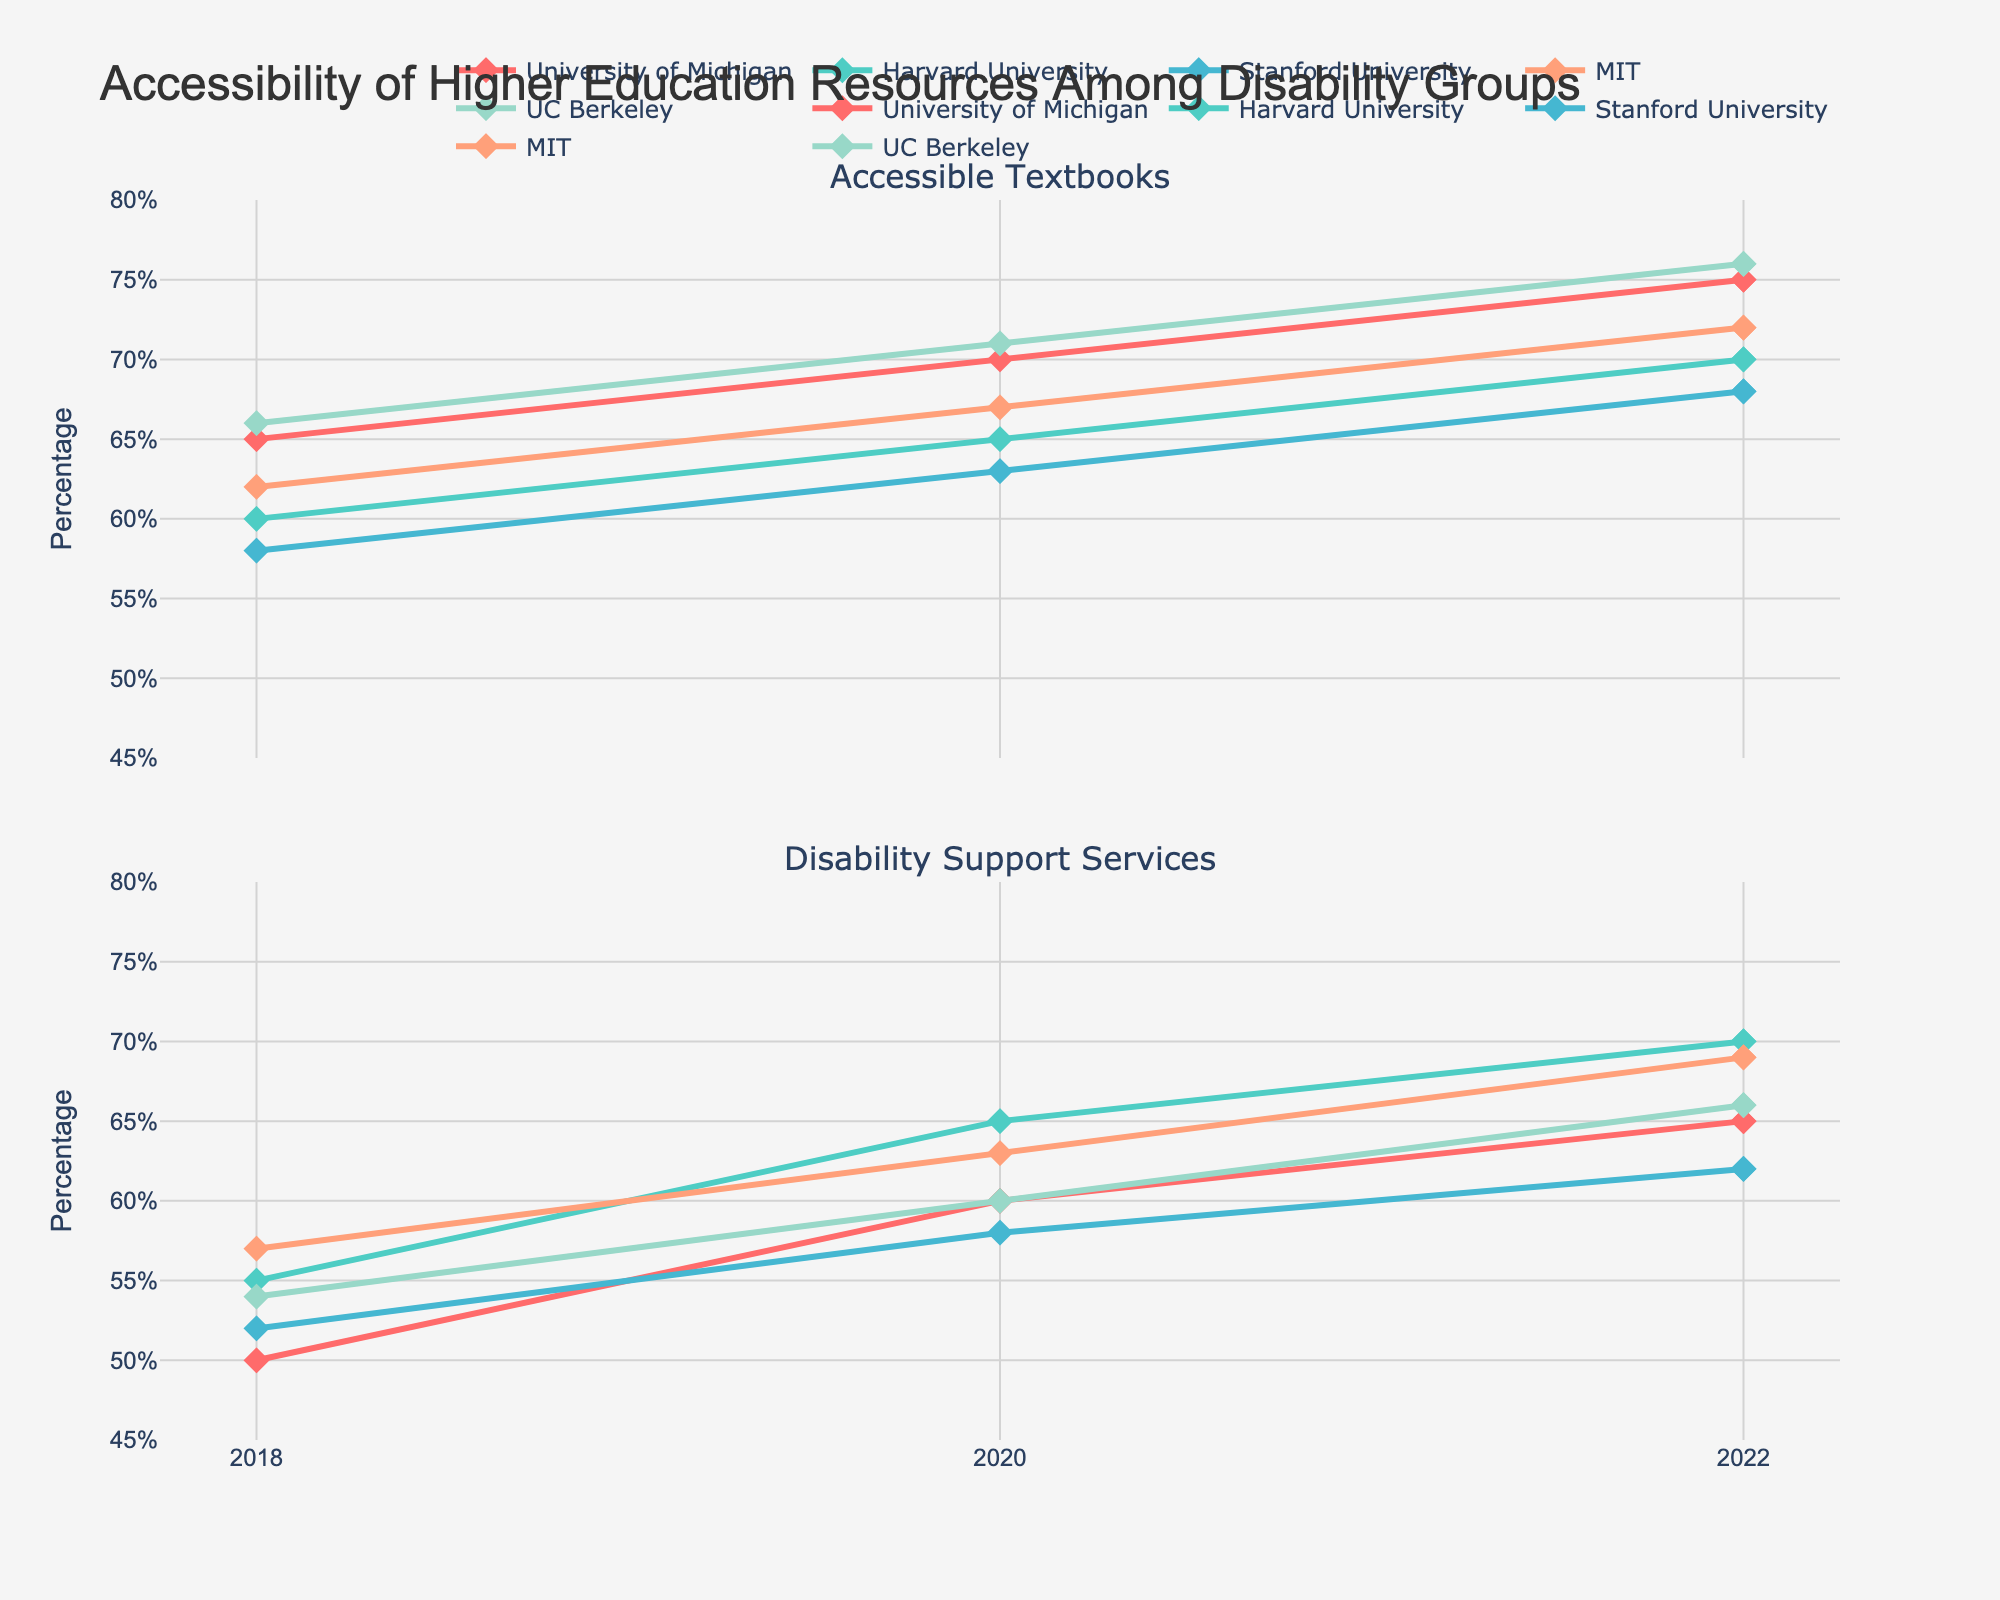What is the title of the figure? The title of the figure is typically displayed prominently at the top of the graph.
Answer: Accessibility of Higher Education Resources Among Disability Groups How many institutions are displayed in the figure? By analyzing the legend or the distinct lines representing different institutions, we can count the number of institutions.
Answer: Five Which institution had the highest percentage of accessible textbooks in 2022? By observing the 'Accessible Textbooks' subplot for 2022 and comparing the endpoints of the lines, the institution with the highest percentage can be identified.
Answer: UC Berkeley What was the percentage increase in accessible textbooks at the University of Michigan from 2018 to 2022? Subtract 2018's percentage from 2022's percentage for the University of Michigan in the 'Accessible Textbooks' subplot: 75% - 65% = 10%.
Answer: 10% Which resource saw the largest improvement at MIT between 2018 and 2022? Compare the changes in percentages for both resources at MIT between 2018 and 2022 to determine the larger improvement. Accessible Textbooks: 72% - 62% = 10%. Disability Support Services: 69% - 57% = 12%.
Answer: Disability Support Services Did any institution have a decrease in either resource from 2018 to 2022? Examine the endpoints of all lines in both subplots; none should show a decline from left to right.
Answer: No Between Harvard and Stanford, which institution had a higher percentage of disability support services in 2020? Compare the data points for 'Disability Support Services' in 2020 for both Harvard and Stanford.
Answer: Harvard What is the average percentage of accessible textbooks across all institutions in 2022? Add the percentages for accessible textbooks in 2022 for all institutions and divide by the number of institutions: (75% + 70% + 68% + 72% + 76%)/5 = 72.2%.
Answer: 72.2% Which institution showed consistent improvements in both resources from 2018 to 2022? Identify institutions with increasing values in both 'Accessible Textbooks' and 'Disability Support Services' subplots across all years.
Answer: All institutions What was the difference in the percentage of disability support services between University of Michigan and UC Berkeley in 2020? Subtract UC Berkeley's percentage from University of Michigan's percentage for 'Disability Support Services' in 2020: 60% - 60% = 0%.
Answer: 0% 